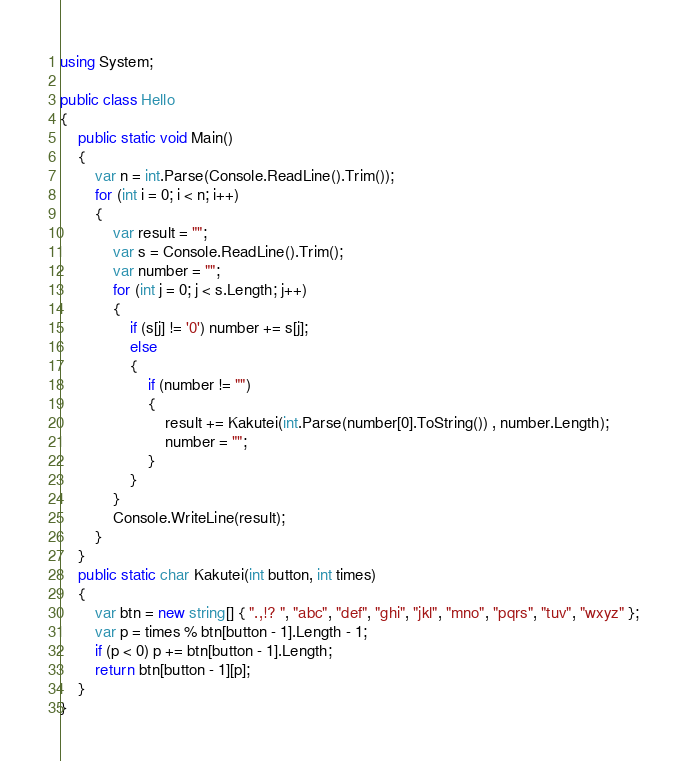Convert code to text. <code><loc_0><loc_0><loc_500><loc_500><_C#_>using System;

public class Hello
{
    public static void Main()
    {
        var n = int.Parse(Console.ReadLine().Trim());
        for (int i = 0; i < n; i++)
        {
            var result = "";
            var s = Console.ReadLine().Trim();
            var number = "";
            for (int j = 0; j < s.Length; j++)
            {
                if (s[j] != '0') number += s[j];
                else
                {
                    if (number != "")
                    {
                        result += Kakutei(int.Parse(number[0].ToString()) , number.Length);
                        number = "";
                    }
                }
            }
            Console.WriteLine(result);
        }
    }
    public static char Kakutei(int button, int times)
    {
        var btn = new string[] { ".,!? ", "abc", "def", "ghi", "jkl", "mno", "pqrs", "tuv", "wxyz" };
        var p = times % btn[button - 1].Length - 1;
        if (p < 0) p += btn[button - 1].Length;
        return btn[button - 1][p];
    }
}</code> 